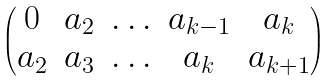<formula> <loc_0><loc_0><loc_500><loc_500>\begin{pmatrix} 0 & a _ { 2 } & \hdots & a _ { k - 1 } & a _ { k } \\ a _ { 2 } & a _ { 3 } & \hdots & a _ { k } & a _ { k + 1 } \end{pmatrix}</formula> 